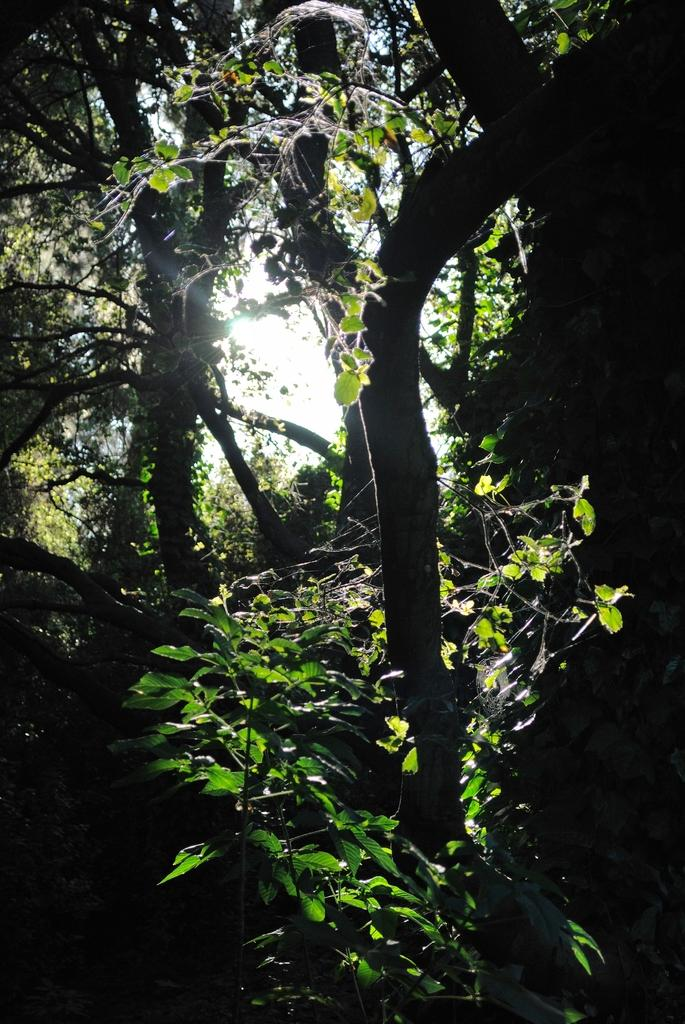What type of vegetation can be seen in the image? There are plants and trees in the image. What part of the natural environment is visible in the image? The sky is visible in the image. What type of degree is the zebra pursuing in the image? There is no zebra present in the image, and therefore no degree-related information can be obtained. 